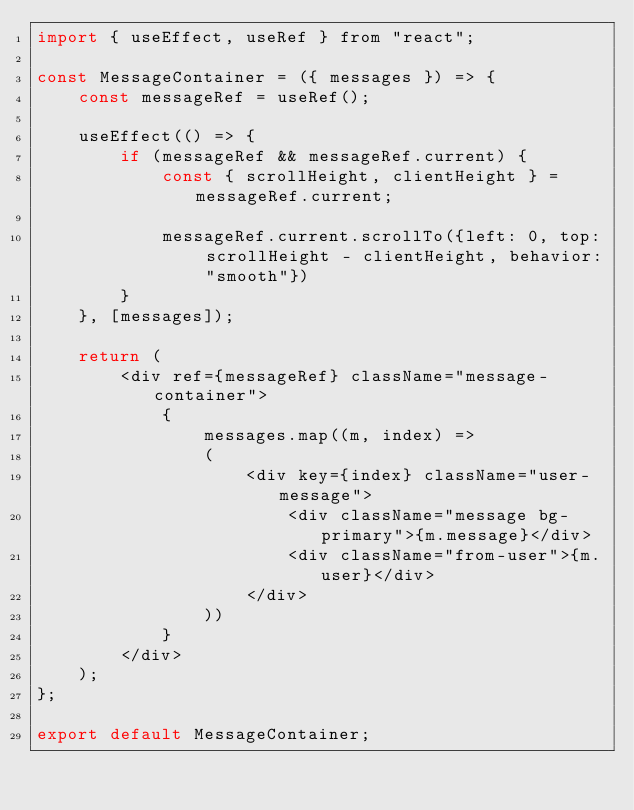Convert code to text. <code><loc_0><loc_0><loc_500><loc_500><_JavaScript_>import { useEffect, useRef } from "react";

const MessageContainer = ({ messages }) => {
    const messageRef = useRef();

    useEffect(() => {
        if (messageRef && messageRef.current) {
            const { scrollHeight, clientHeight } = messageRef.current;
            
            messageRef.current.scrollTo({left: 0, top: scrollHeight - clientHeight, behavior: "smooth"})
        }
    }, [messages]);

    return (
        <div ref={messageRef} className="message-container">
            {
                messages.map((m, index) =>
                (
                    <div key={index} className="user-message">
                        <div className="message bg-primary">{m.message}</div>
                        <div className="from-user">{m.user}</div>
                    </div>
                ))
            }
        </div>
    );
};

export default MessageContainer;</code> 